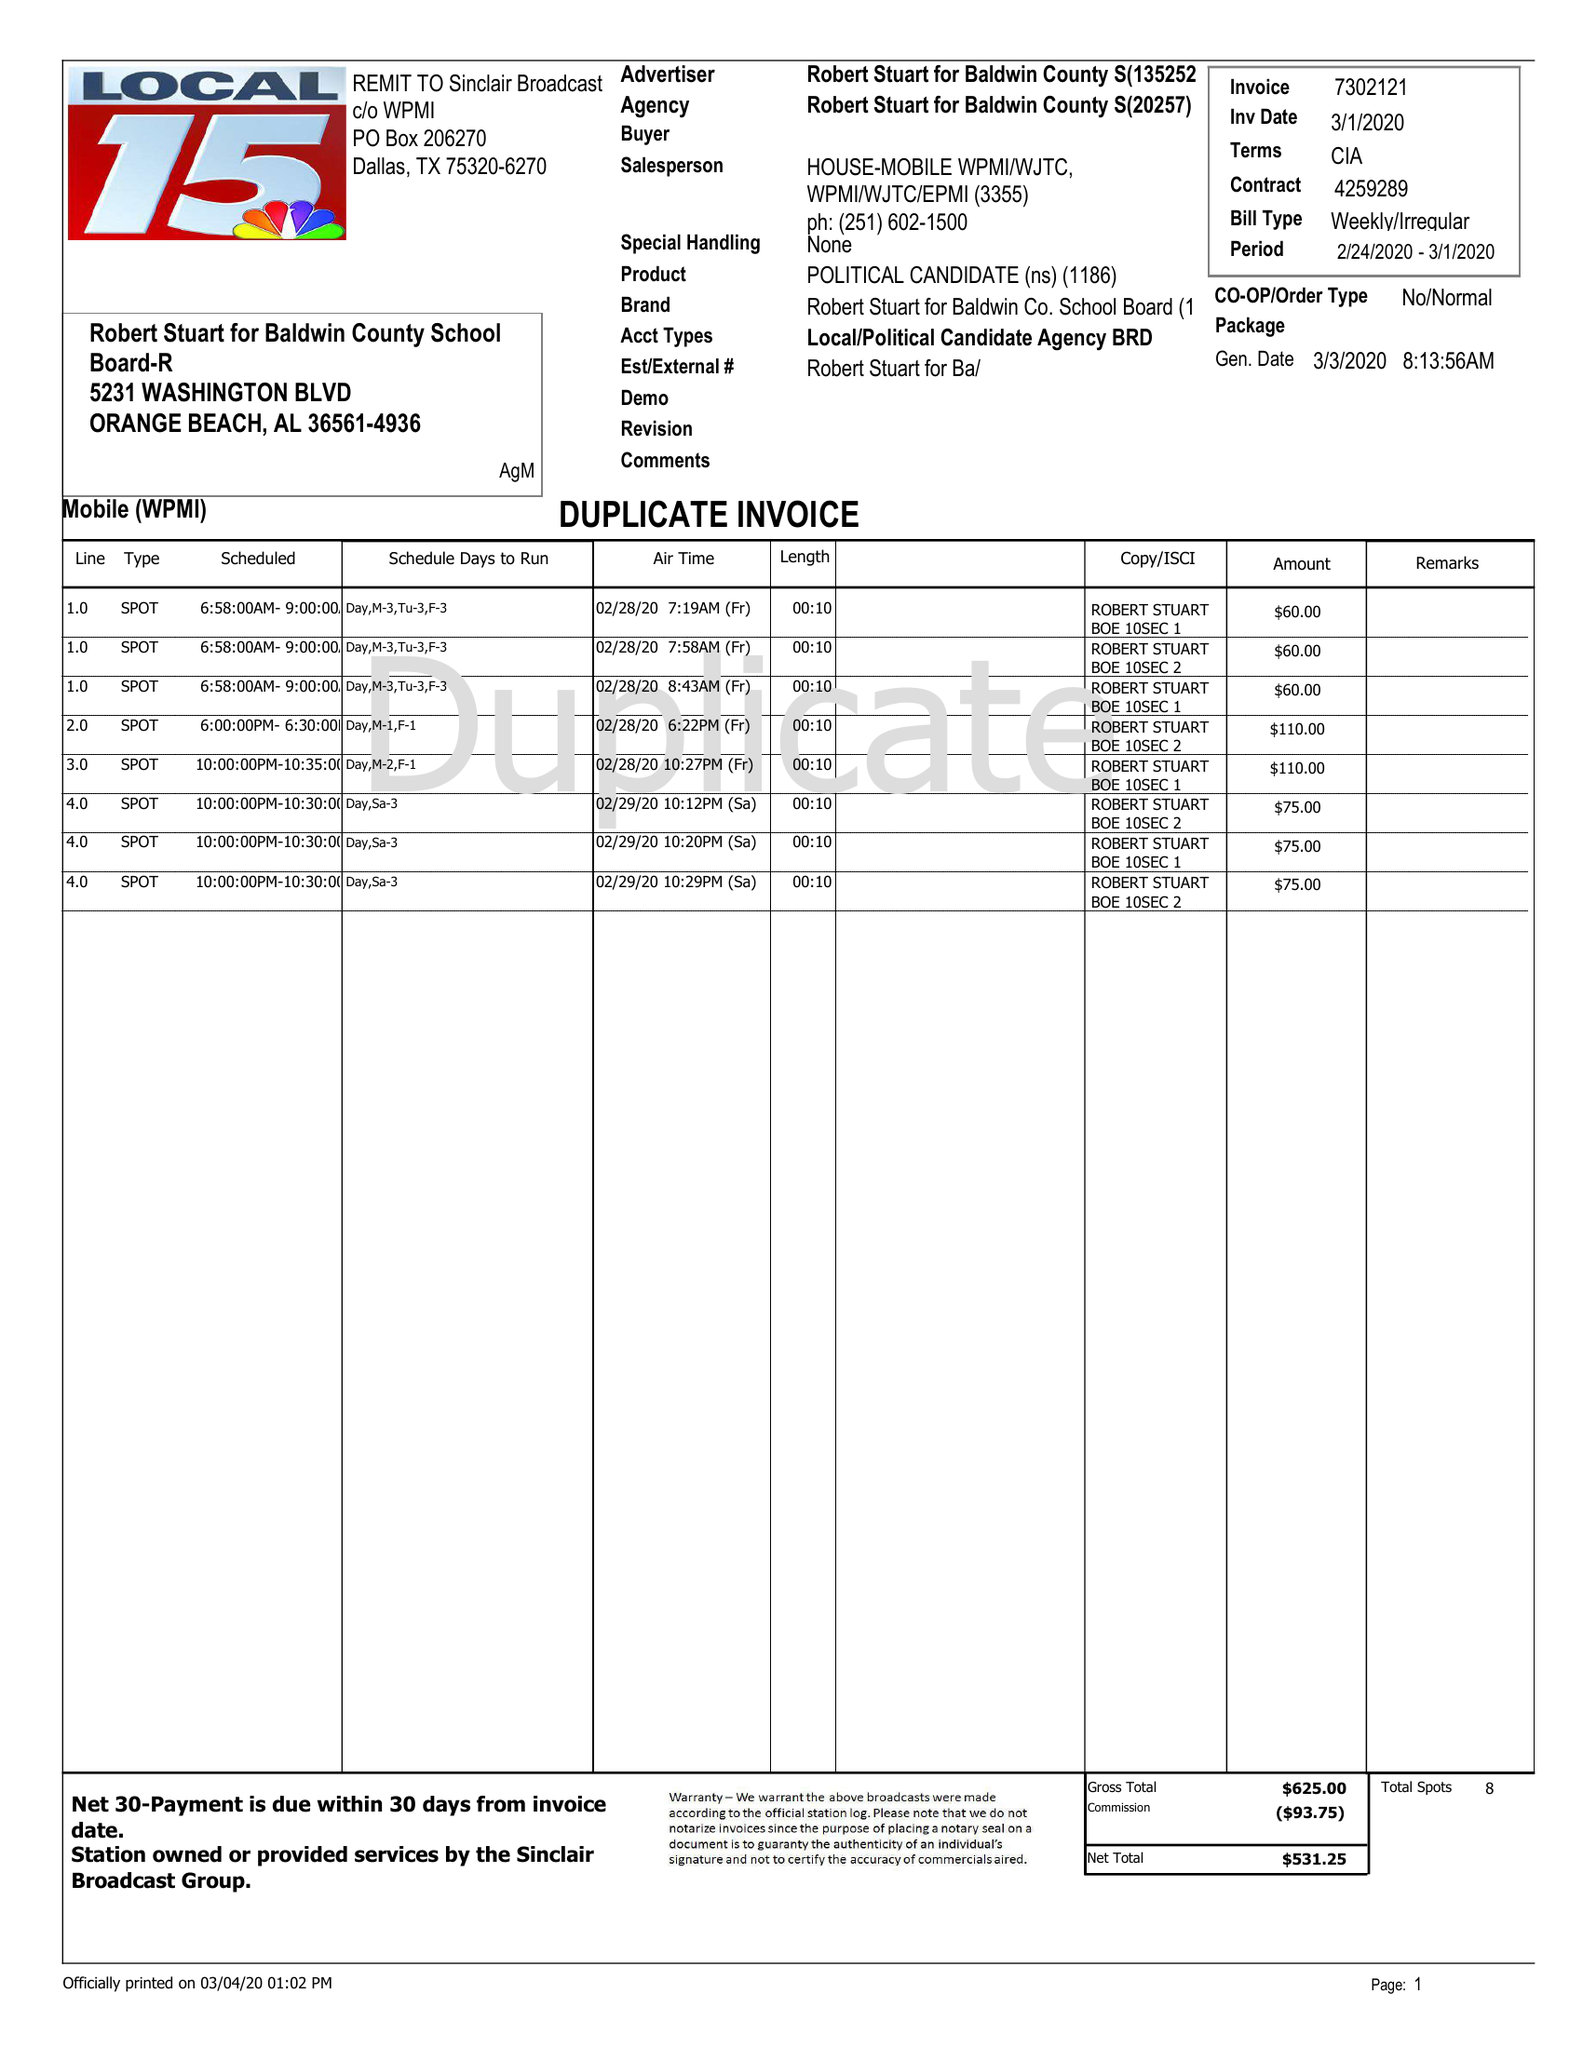What is the value for the gross_amount?
Answer the question using a single word or phrase. 625.00 